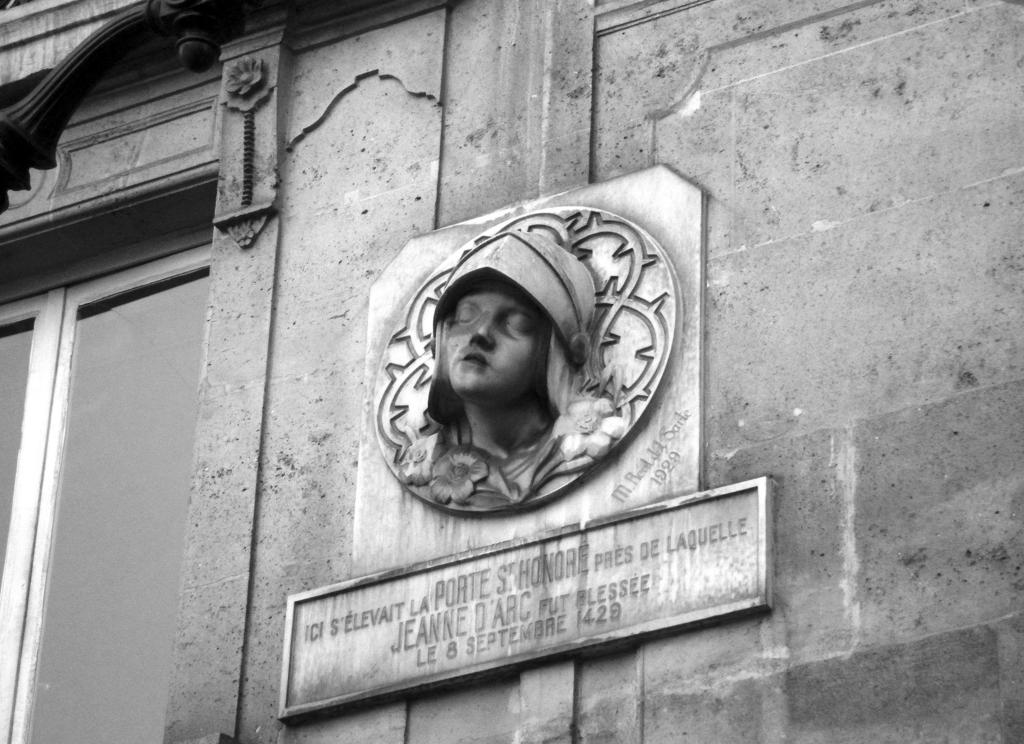What is depicted on the wall in the image? There is a sculpture of a person on the wall. What other features can be seen on the wall? The wall has a window and a name board attached to it. What is the price of the hill visible through the window in the image? There is no hill visible through the window in the image, and therefore no price can be determined. 